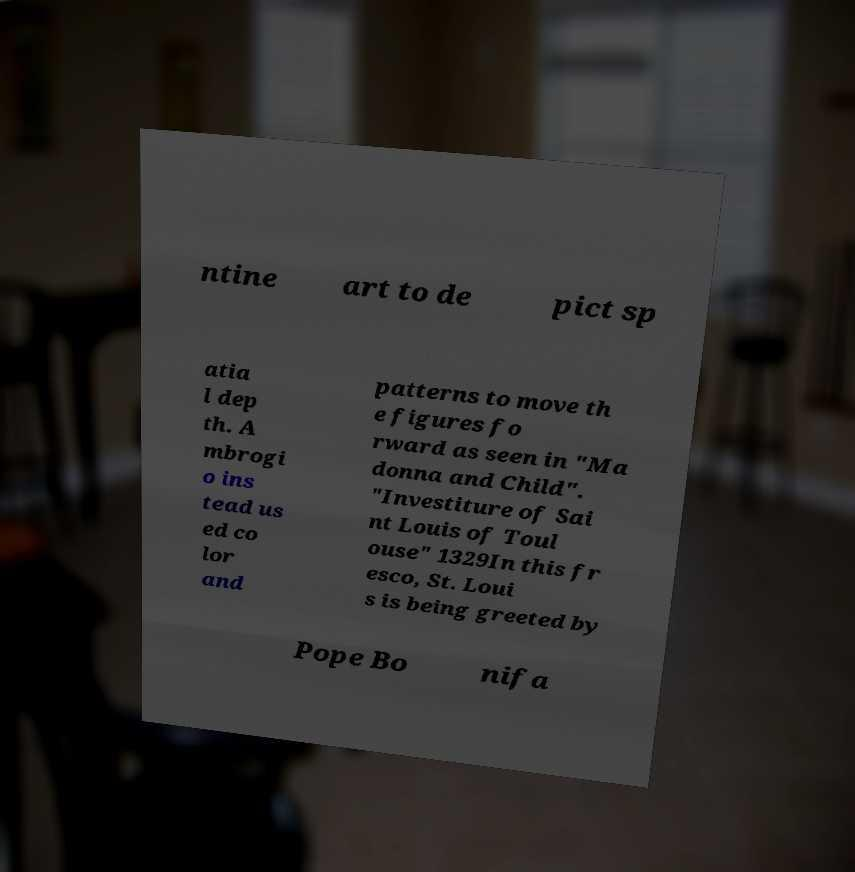Please identify and transcribe the text found in this image. ntine art to de pict sp atia l dep th. A mbrogi o ins tead us ed co lor and patterns to move th e figures fo rward as seen in "Ma donna and Child". "Investiture of Sai nt Louis of Toul ouse" 1329In this fr esco, St. Loui s is being greeted by Pope Bo nifa 